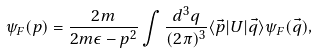Convert formula to latex. <formula><loc_0><loc_0><loc_500><loc_500>\psi _ { F } ( p ) = \frac { 2 m } { 2 m \epsilon - p ^ { 2 } } \int { \frac { d ^ { 3 } q } { ( 2 \pi ) ^ { 3 } } \langle \vec { p } | U | \vec { q } \rangle \psi _ { F } ( \vec { q } ) } ,</formula> 